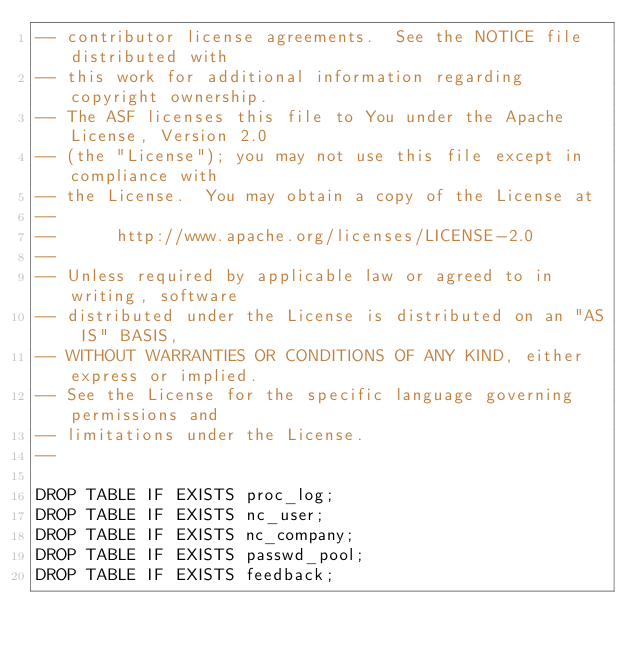Convert code to text. <code><loc_0><loc_0><loc_500><loc_500><_SQL_>-- contributor license agreements.  See the NOTICE file distributed with
-- this work for additional information regarding copyright ownership.
-- The ASF licenses this file to You under the Apache License, Version 2.0
-- (the "License"); you may not use this file except in compliance with
-- the License.  You may obtain a copy of the License at
--
--      http://www.apache.org/licenses/LICENSE-2.0
--
-- Unless required by applicable law or agreed to in writing, software
-- distributed under the License is distributed on an "AS IS" BASIS,
-- WITHOUT WARRANTIES OR CONDITIONS OF ANY KIND, either express or implied.
-- See the License for the specific language governing permissions and
-- limitations under the License.
--

DROP TABLE IF EXISTS proc_log;
DROP TABLE IF EXISTS nc_user;
DROP TABLE IF EXISTS nc_company;
DROP TABLE IF EXISTS passwd_pool;
DROP TABLE IF EXISTS feedback;</code> 